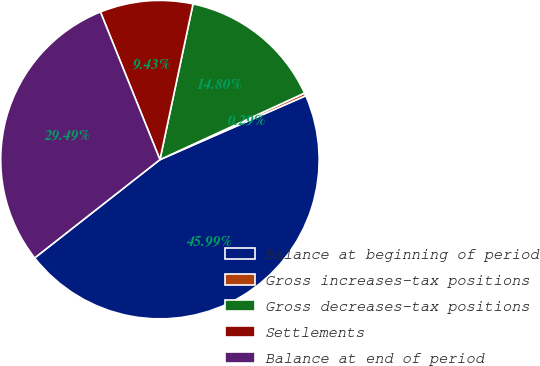Convert chart. <chart><loc_0><loc_0><loc_500><loc_500><pie_chart><fcel>Balance at beginning of period<fcel>Gross increases-tax positions<fcel>Gross decreases-tax positions<fcel>Settlements<fcel>Balance at end of period<nl><fcel>45.99%<fcel>0.29%<fcel>14.8%<fcel>9.43%<fcel>29.49%<nl></chart> 